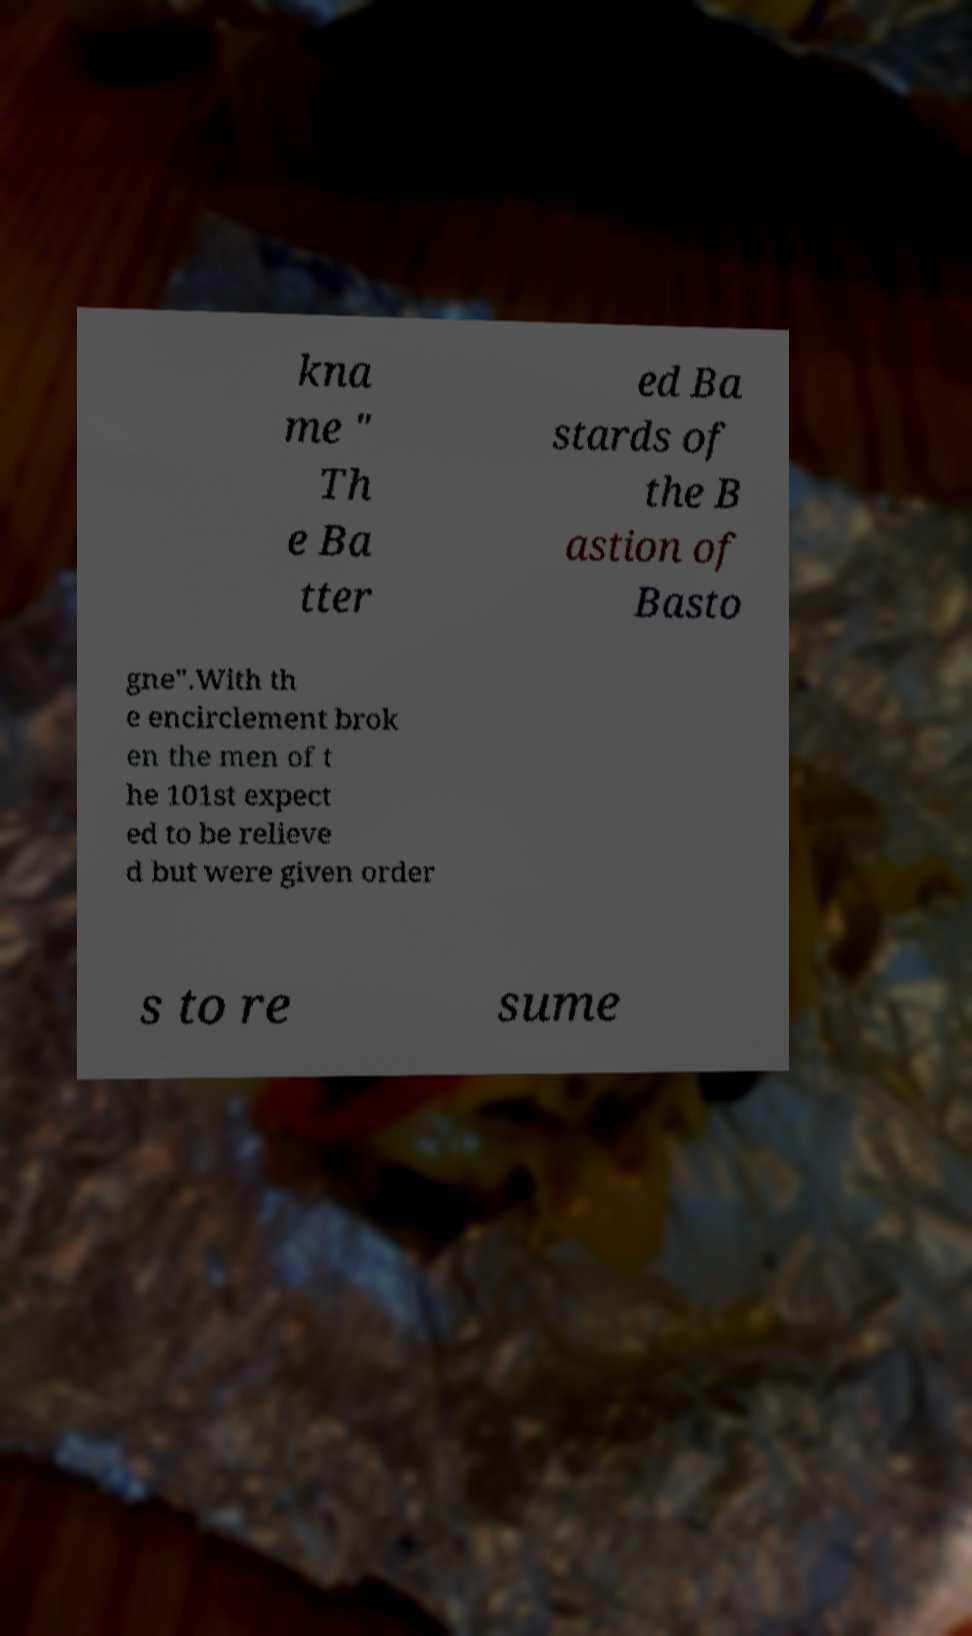Please read and relay the text visible in this image. What does it say? kna me " Th e Ba tter ed Ba stards of the B astion of Basto gne".With th e encirclement brok en the men of t he 101st expect ed to be relieve d but were given order s to re sume 